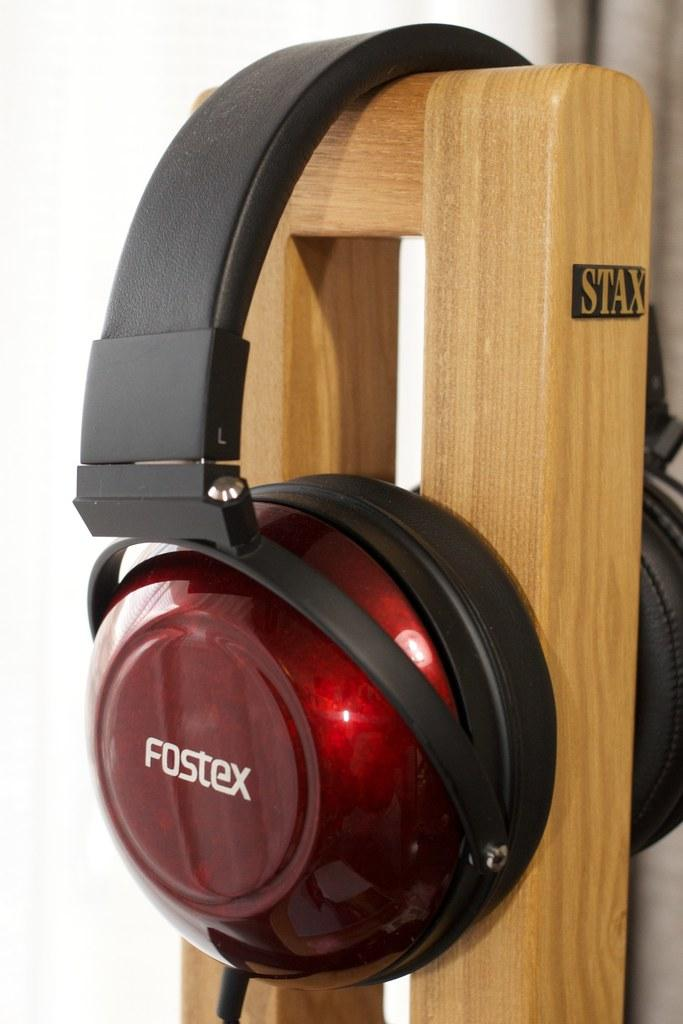What can be seen in the image related to audio equipment? There is a headset in the image. How is the headset positioned in the image? The headset is placed on a stand. What type of shock can be seen affecting the headset in the image? There is no shock affecting the headset in the image; it is simply placed on a stand. 